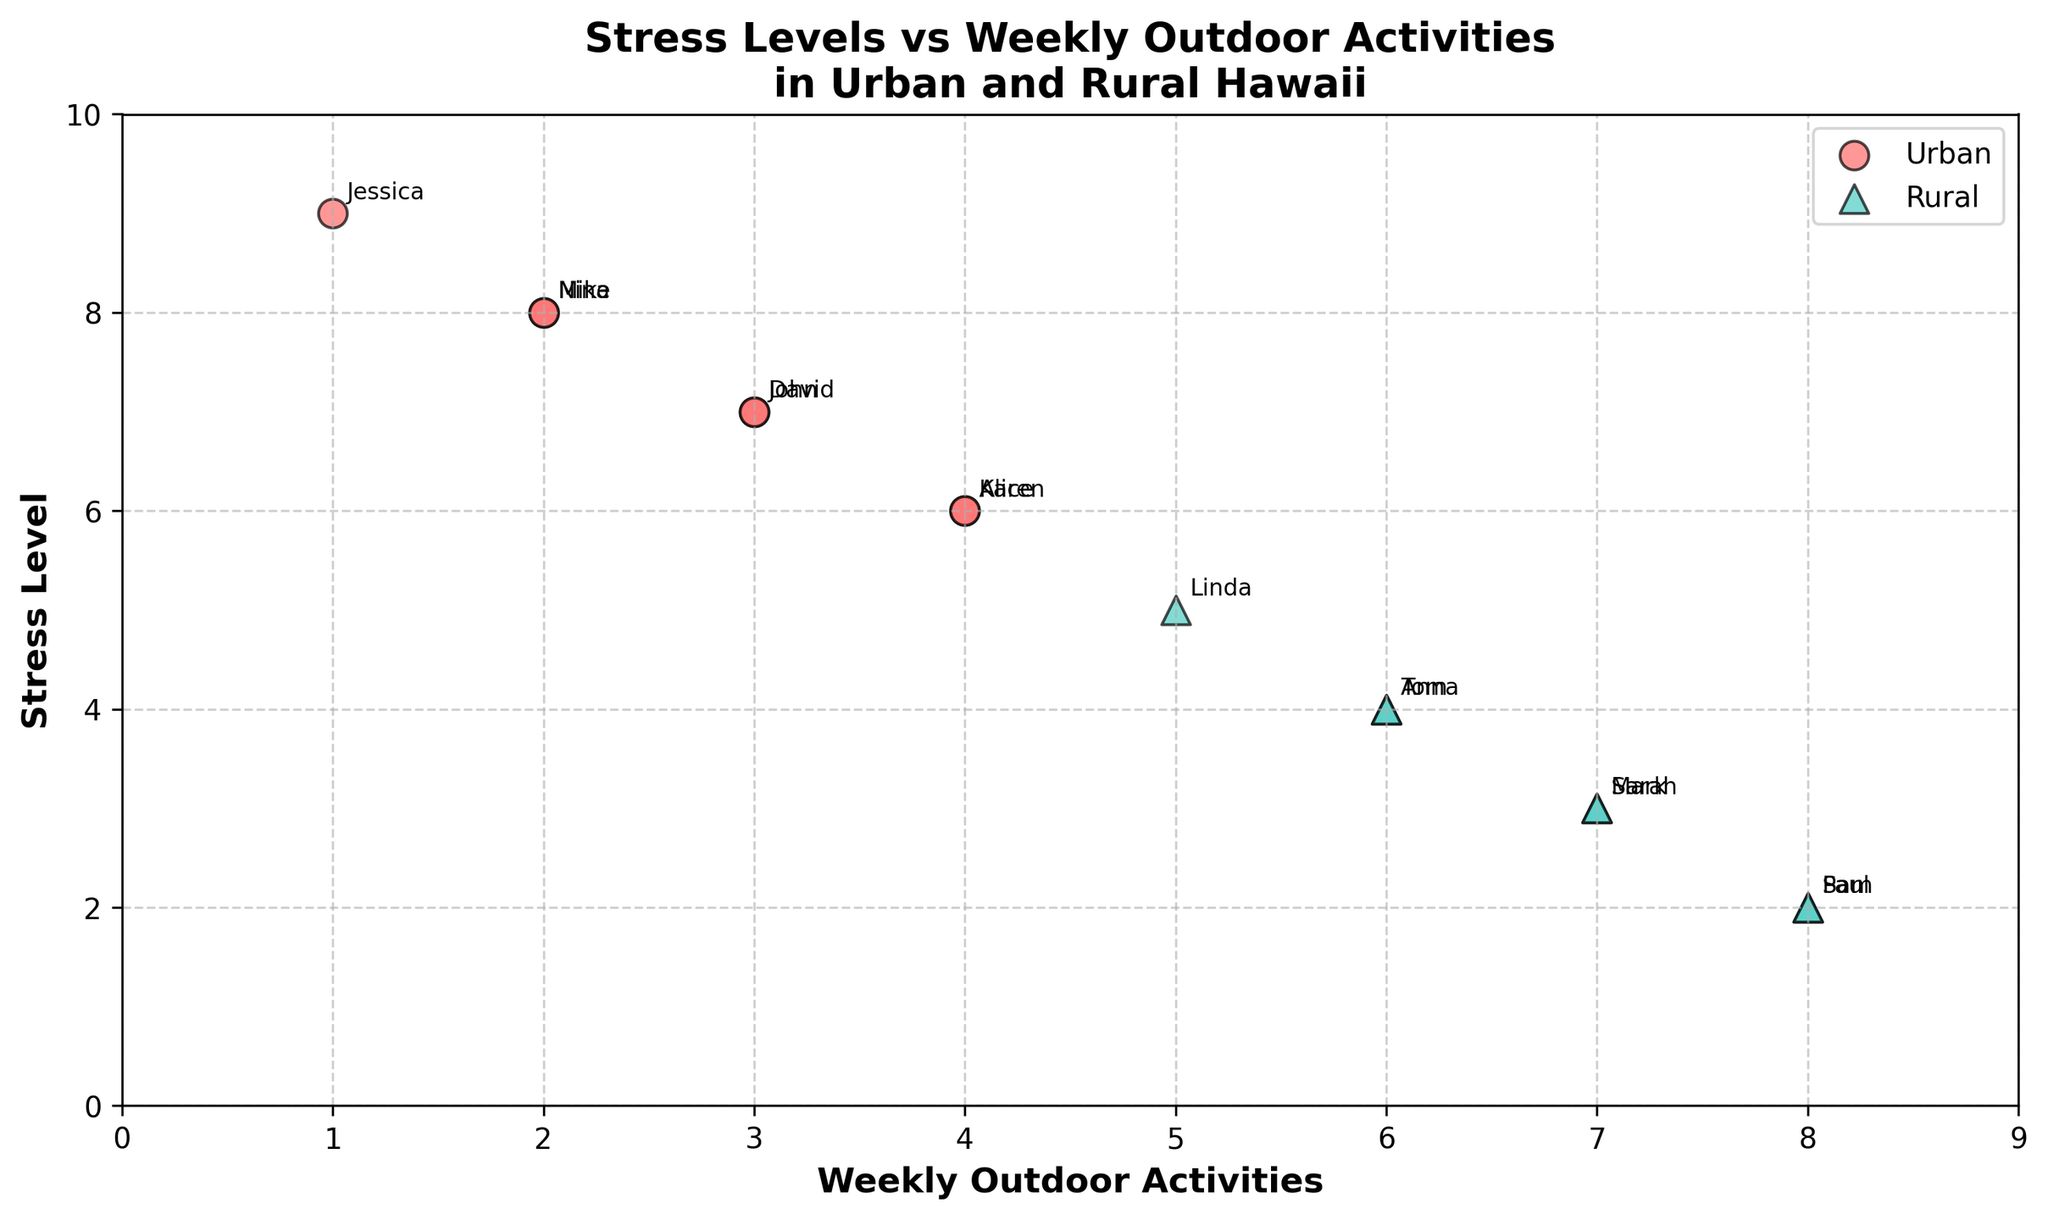How many urban and rural residents are shown in the figure? Identify the number of data points labeled as 'Urban' and 'Rural' in the scatter plot. There are 6 urban residents and 8 rural residents.
Answer: There are 6 urban and 8 rural residents What is the title of the figure? The title is usually located at the top of the figure. Here, the title reads "Stress Levels vs Weekly Outdoor Activities in Urban and Rural Hawaii."
Answer: Stress Levels vs Weekly Outdoor Activities in Urban and Rural Hawaii What color represents urban residents in the figure? The color used for urban residents' data points should be identified. In this figure, urban residents are represented by red-colored circles.
Answer: Red Who is the urban resident with the highest stress level, and what is their weekly outdoor activity level? Look for the red-colored circle with the highest position along the stress level axis (Y-axis). This is Jessica, who has a stress level of 9 and engages in 1 weekly outdoor activity.
Answer: Jessica, 1 weekly outdoor activity Which group appears to have lower stress levels overall: urban or rural residents? Compare the general distribution of data points for urban and rural residents along the stress level axis. Rural residents, represented by green, generally seem to have lower stress levels compared to the urban residents.
Answer: Rural residents What is the range of weekly outdoor activities for the rural residents? Determine the minimum and maximum weekly outdoor activities by checking the positions of rural residents along the weekly outdoor activities axis (X-axis). The range spans from 5 to 8.
Answer: 5 to 8 Are there any residents with the same stress level and weekly outdoor activity count? If so, who are they and what are these values? Identify any overlapping points (coordinates) on the scatter plot for both urban and rural groups. Karen and Alice (urban residents) both have 4 weekly outdoor activities and a stress level of 6.
Answer: Karen and Alice, 4 activities, stress level of 6 What is the average stress level for rural residents? Sum the stress levels of all rural residents and divide by the number of rural residents. Stress levels: 3, 4, 2, 5, 3, 4, 2. (3+4+2+5+3+4+2) / 7 = 3.29 (approximately)
Answer: 3.29 Do any urban residents have a stress level lower than the highest stress level of rural residents? If so, who are they? Identify the highest stress level among rural residents and see if any urban resident has a lower stress level. The highest stress level among rural residents is 5, and urban residents with lower stress levels are John and David, both with a stress level of 7.
Answer: No What's the most common stress level among the urban residents? Observe the scatter plot and count the frequency of each stress level for urban residents. The stress level of 7 appears twice, which is the most common.
Answer: 7 